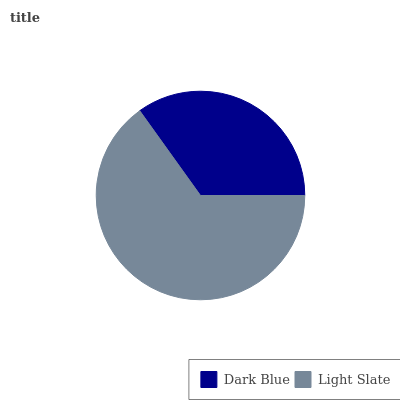Is Dark Blue the minimum?
Answer yes or no. Yes. Is Light Slate the maximum?
Answer yes or no. Yes. Is Light Slate the minimum?
Answer yes or no. No. Is Light Slate greater than Dark Blue?
Answer yes or no. Yes. Is Dark Blue less than Light Slate?
Answer yes or no. Yes. Is Dark Blue greater than Light Slate?
Answer yes or no. No. Is Light Slate less than Dark Blue?
Answer yes or no. No. Is Light Slate the high median?
Answer yes or no. Yes. Is Dark Blue the low median?
Answer yes or no. Yes. Is Dark Blue the high median?
Answer yes or no. No. Is Light Slate the low median?
Answer yes or no. No. 